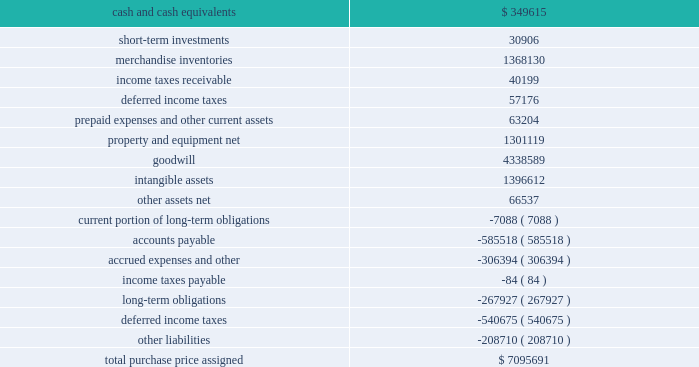Dollar general corporation and subsidiaries notes to consolidated financial statements ( continued ) 3 .
Merger ( continued ) merger as a subsidiary of buck .
The company 2019s results of operations after july 6 , 2007 include the effects of the merger .
The aggregate purchase price was approximately $ 7.1 billion , including direct costs of the merger , and was funded primarily through debt financings as described more fully below in note 7 and cash equity contributions from kkr , gs capital partners vi fund , l.p .
And affiliated funds ( affiliates of goldman , sachs & co. ) , and other equity co-investors ( collectively , the 2018 2018investors 2019 2019 of approximately $ 2.8 billion ( 316.2 million shares of new common stock , $ 0.875 par value per share , valued at $ 8.75 per share ) .
Also in connection with the merger , certain of the company 2019s management employees invested in and were issued new shares , representing less than 1% ( 1 % ) of the outstanding shares , in the company .
Pursuant to the terms of the merger agreement , the former holders of the predecessor 2019s common stock , par value $ 0.50 per share , received $ 22.00 per share , or approximately $ 6.9 billion , and all such shares were acquired as a result of the merger .
As discussed in note 1 , the merger was accounted for as a reverse acquisition in accordance with applicable purchase accounting provisions .
Because of this accounting treatment , the company 2019s assets and liabilities have properly been accounted for at their estimated fair values as of the merger date .
The aggregate purchase price has been allocated to the tangible and intangible assets acquired and liabilities assumed based upon an assessment of their relative fair values as of the merger date .
The allocation of the purchase price is as follows ( in thousands ) : .
The purchase price allocation included approximately $ 4.34 billion of goodwill , none of which is expected to be deductible for tax purposes .
The goodwill balance at january 30 , 2009 decreased $ 6.3 million from the balance at february 1 , 2008 due to an adjustment to income tax contingencies as further discussed in note 6. .
What percentage of the purchase price was hard assets? 
Rationale: ppe - hard assets
Computations: (1301119 / 7095691)
Answer: 0.18337. 